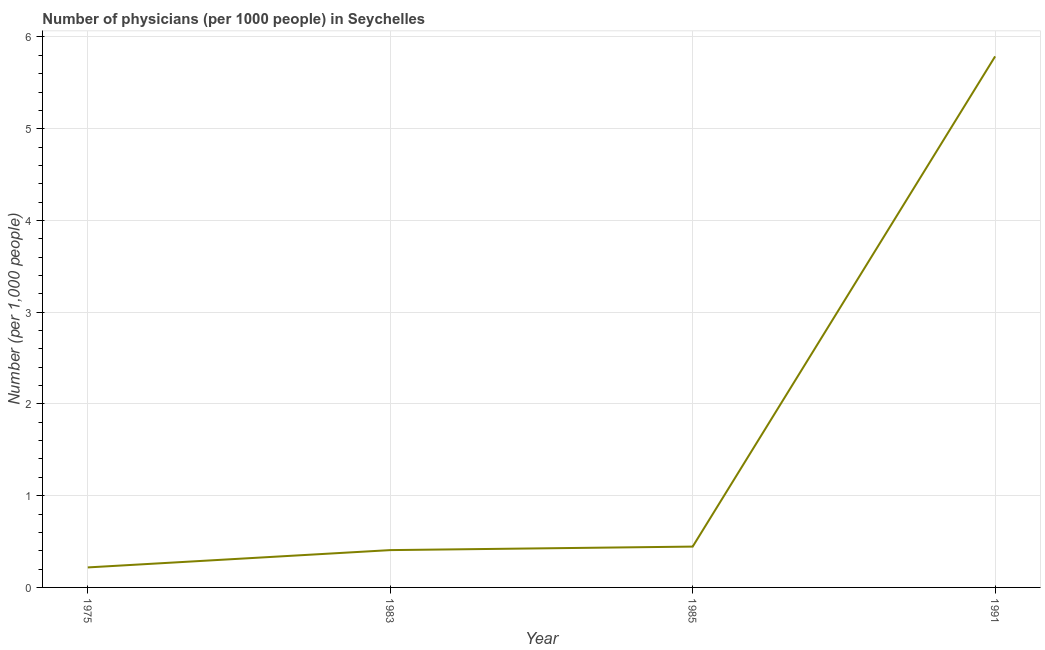What is the number of physicians in 1985?
Provide a succinct answer. 0.45. Across all years, what is the maximum number of physicians?
Your answer should be very brief. 5.79. Across all years, what is the minimum number of physicians?
Your answer should be compact. 0.22. In which year was the number of physicians minimum?
Give a very brief answer. 1975. What is the sum of the number of physicians?
Your response must be concise. 6.86. What is the difference between the number of physicians in 1983 and 1991?
Your answer should be compact. -5.38. What is the average number of physicians per year?
Give a very brief answer. 1.71. What is the median number of physicians?
Make the answer very short. 0.43. What is the ratio of the number of physicians in 1985 to that in 1991?
Your answer should be very brief. 0.08. What is the difference between the highest and the second highest number of physicians?
Your answer should be very brief. 5.34. Is the sum of the number of physicians in 1983 and 1991 greater than the maximum number of physicians across all years?
Make the answer very short. Yes. What is the difference between the highest and the lowest number of physicians?
Ensure brevity in your answer.  5.57. In how many years, is the number of physicians greater than the average number of physicians taken over all years?
Provide a succinct answer. 1. Does the number of physicians monotonically increase over the years?
Your answer should be very brief. Yes. How many lines are there?
Offer a terse response. 1. What is the difference between two consecutive major ticks on the Y-axis?
Keep it short and to the point. 1. Does the graph contain grids?
Ensure brevity in your answer.  Yes. What is the title of the graph?
Your response must be concise. Number of physicians (per 1000 people) in Seychelles. What is the label or title of the X-axis?
Give a very brief answer. Year. What is the label or title of the Y-axis?
Provide a succinct answer. Number (per 1,0 people). What is the Number (per 1,000 people) of 1975?
Give a very brief answer. 0.22. What is the Number (per 1,000 people) in 1983?
Your answer should be compact. 0.41. What is the Number (per 1,000 people) in 1985?
Ensure brevity in your answer.  0.45. What is the Number (per 1,000 people) of 1991?
Your answer should be very brief. 5.79. What is the difference between the Number (per 1,000 people) in 1975 and 1983?
Your response must be concise. -0.19. What is the difference between the Number (per 1,000 people) in 1975 and 1985?
Provide a succinct answer. -0.23. What is the difference between the Number (per 1,000 people) in 1975 and 1991?
Your answer should be very brief. -5.57. What is the difference between the Number (per 1,000 people) in 1983 and 1985?
Offer a terse response. -0.04. What is the difference between the Number (per 1,000 people) in 1983 and 1991?
Your response must be concise. -5.38. What is the difference between the Number (per 1,000 people) in 1985 and 1991?
Your answer should be very brief. -5.34. What is the ratio of the Number (per 1,000 people) in 1975 to that in 1983?
Provide a short and direct response. 0.54. What is the ratio of the Number (per 1,000 people) in 1975 to that in 1985?
Offer a very short reply. 0.49. What is the ratio of the Number (per 1,000 people) in 1975 to that in 1991?
Your answer should be very brief. 0.04. What is the ratio of the Number (per 1,000 people) in 1983 to that in 1985?
Ensure brevity in your answer.  0.91. What is the ratio of the Number (per 1,000 people) in 1983 to that in 1991?
Provide a succinct answer. 0.07. What is the ratio of the Number (per 1,000 people) in 1985 to that in 1991?
Make the answer very short. 0.08. 